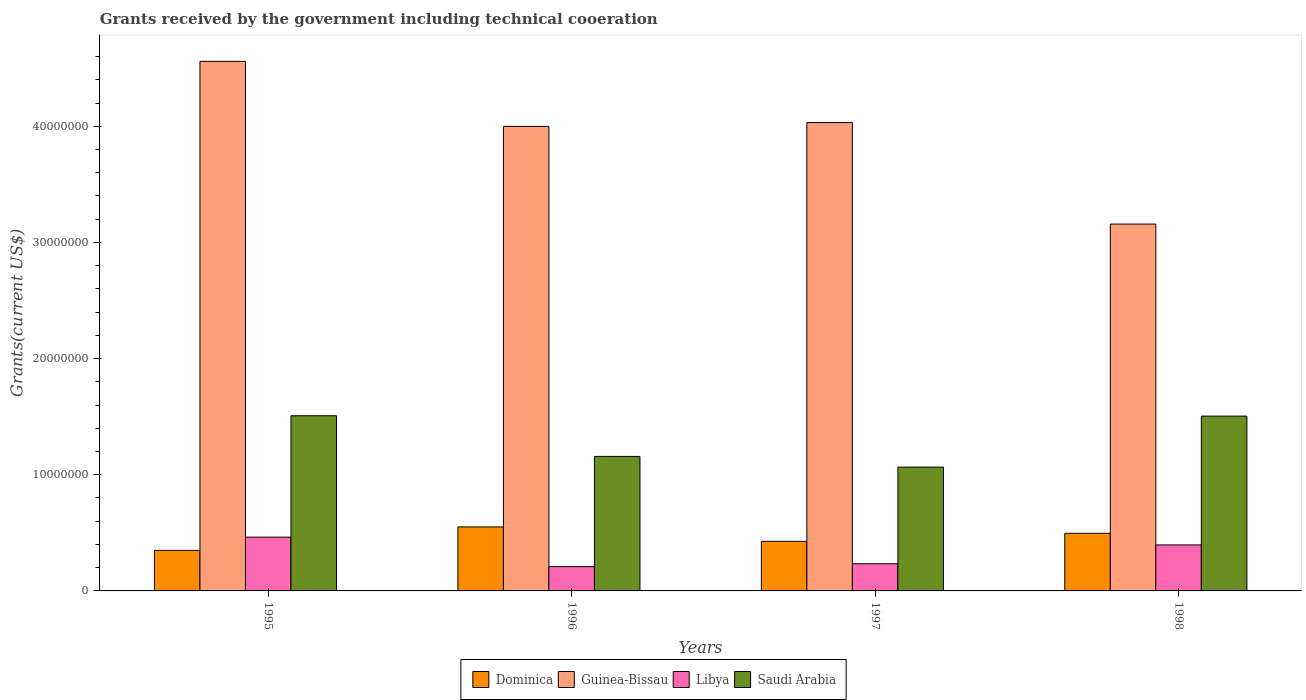How many different coloured bars are there?
Offer a very short reply. 4. How many groups of bars are there?
Your response must be concise. 4. Are the number of bars per tick equal to the number of legend labels?
Your answer should be very brief. Yes. In how many cases, is the number of bars for a given year not equal to the number of legend labels?
Your response must be concise. 0. What is the total grants received by the government in Saudi Arabia in 1995?
Provide a succinct answer. 1.51e+07. Across all years, what is the maximum total grants received by the government in Saudi Arabia?
Give a very brief answer. 1.51e+07. Across all years, what is the minimum total grants received by the government in Saudi Arabia?
Your answer should be very brief. 1.07e+07. In which year was the total grants received by the government in Saudi Arabia maximum?
Keep it short and to the point. 1995. What is the total total grants received by the government in Dominica in the graph?
Your answer should be very brief. 1.82e+07. What is the difference between the total grants received by the government in Guinea-Bissau in 1995 and that in 1998?
Provide a short and direct response. 1.40e+07. What is the difference between the total grants received by the government in Guinea-Bissau in 1998 and the total grants received by the government in Libya in 1995?
Offer a terse response. 2.70e+07. What is the average total grants received by the government in Dominica per year?
Your answer should be very brief. 4.56e+06. In the year 1998, what is the difference between the total grants received by the government in Libya and total grants received by the government in Saudi Arabia?
Ensure brevity in your answer.  -1.11e+07. In how many years, is the total grants received by the government in Dominica greater than 20000000 US$?
Ensure brevity in your answer.  0. What is the ratio of the total grants received by the government in Saudi Arabia in 1997 to that in 1998?
Offer a terse response. 0.71. Is the total grants received by the government in Libya in 1996 less than that in 1998?
Offer a terse response. Yes. Is the difference between the total grants received by the government in Libya in 1995 and 1998 greater than the difference between the total grants received by the government in Saudi Arabia in 1995 and 1998?
Provide a short and direct response. Yes. What is the difference between the highest and the second highest total grants received by the government in Saudi Arabia?
Give a very brief answer. 3.00e+04. What is the difference between the highest and the lowest total grants received by the government in Guinea-Bissau?
Make the answer very short. 1.40e+07. In how many years, is the total grants received by the government in Libya greater than the average total grants received by the government in Libya taken over all years?
Give a very brief answer. 2. Is it the case that in every year, the sum of the total grants received by the government in Guinea-Bissau and total grants received by the government in Dominica is greater than the sum of total grants received by the government in Saudi Arabia and total grants received by the government in Libya?
Your answer should be very brief. Yes. What does the 2nd bar from the left in 1998 represents?
Offer a very short reply. Guinea-Bissau. What does the 1st bar from the right in 1998 represents?
Make the answer very short. Saudi Arabia. Is it the case that in every year, the sum of the total grants received by the government in Libya and total grants received by the government in Saudi Arabia is greater than the total grants received by the government in Guinea-Bissau?
Your answer should be compact. No. How many bars are there?
Ensure brevity in your answer.  16. Are all the bars in the graph horizontal?
Give a very brief answer. No. What is the difference between two consecutive major ticks on the Y-axis?
Ensure brevity in your answer.  1.00e+07. Are the values on the major ticks of Y-axis written in scientific E-notation?
Offer a terse response. No. Does the graph contain any zero values?
Ensure brevity in your answer.  No. Does the graph contain grids?
Provide a short and direct response. No. Where does the legend appear in the graph?
Give a very brief answer. Bottom center. What is the title of the graph?
Make the answer very short. Grants received by the government including technical cooeration. Does "Congo (Democratic)" appear as one of the legend labels in the graph?
Provide a short and direct response. No. What is the label or title of the Y-axis?
Your answer should be compact. Grants(current US$). What is the Grants(current US$) in Dominica in 1995?
Give a very brief answer. 3.49e+06. What is the Grants(current US$) of Guinea-Bissau in 1995?
Your answer should be compact. 4.56e+07. What is the Grants(current US$) in Libya in 1995?
Make the answer very short. 4.63e+06. What is the Grants(current US$) of Saudi Arabia in 1995?
Offer a terse response. 1.51e+07. What is the Grants(current US$) in Dominica in 1996?
Keep it short and to the point. 5.51e+06. What is the Grants(current US$) of Guinea-Bissau in 1996?
Provide a succinct answer. 4.00e+07. What is the Grants(current US$) in Libya in 1996?
Offer a terse response. 2.09e+06. What is the Grants(current US$) of Saudi Arabia in 1996?
Make the answer very short. 1.16e+07. What is the Grants(current US$) in Dominica in 1997?
Provide a succinct answer. 4.27e+06. What is the Grants(current US$) in Guinea-Bissau in 1997?
Give a very brief answer. 4.03e+07. What is the Grants(current US$) of Libya in 1997?
Make the answer very short. 2.34e+06. What is the Grants(current US$) of Saudi Arabia in 1997?
Give a very brief answer. 1.07e+07. What is the Grants(current US$) in Dominica in 1998?
Your answer should be compact. 4.96e+06. What is the Grants(current US$) in Guinea-Bissau in 1998?
Give a very brief answer. 3.16e+07. What is the Grants(current US$) of Libya in 1998?
Offer a very short reply. 3.96e+06. What is the Grants(current US$) of Saudi Arabia in 1998?
Offer a very short reply. 1.50e+07. Across all years, what is the maximum Grants(current US$) of Dominica?
Give a very brief answer. 5.51e+06. Across all years, what is the maximum Grants(current US$) in Guinea-Bissau?
Your answer should be very brief. 4.56e+07. Across all years, what is the maximum Grants(current US$) of Libya?
Keep it short and to the point. 4.63e+06. Across all years, what is the maximum Grants(current US$) of Saudi Arabia?
Your answer should be very brief. 1.51e+07. Across all years, what is the minimum Grants(current US$) of Dominica?
Offer a very short reply. 3.49e+06. Across all years, what is the minimum Grants(current US$) in Guinea-Bissau?
Give a very brief answer. 3.16e+07. Across all years, what is the minimum Grants(current US$) of Libya?
Your answer should be compact. 2.09e+06. Across all years, what is the minimum Grants(current US$) in Saudi Arabia?
Keep it short and to the point. 1.07e+07. What is the total Grants(current US$) of Dominica in the graph?
Provide a succinct answer. 1.82e+07. What is the total Grants(current US$) in Guinea-Bissau in the graph?
Make the answer very short. 1.57e+08. What is the total Grants(current US$) in Libya in the graph?
Your answer should be compact. 1.30e+07. What is the total Grants(current US$) in Saudi Arabia in the graph?
Offer a very short reply. 5.24e+07. What is the difference between the Grants(current US$) of Dominica in 1995 and that in 1996?
Your answer should be compact. -2.02e+06. What is the difference between the Grants(current US$) in Guinea-Bissau in 1995 and that in 1996?
Offer a terse response. 5.60e+06. What is the difference between the Grants(current US$) of Libya in 1995 and that in 1996?
Ensure brevity in your answer.  2.54e+06. What is the difference between the Grants(current US$) of Saudi Arabia in 1995 and that in 1996?
Offer a very short reply. 3.50e+06. What is the difference between the Grants(current US$) in Dominica in 1995 and that in 1997?
Your response must be concise. -7.80e+05. What is the difference between the Grants(current US$) of Guinea-Bissau in 1995 and that in 1997?
Offer a terse response. 5.27e+06. What is the difference between the Grants(current US$) in Libya in 1995 and that in 1997?
Keep it short and to the point. 2.29e+06. What is the difference between the Grants(current US$) of Saudi Arabia in 1995 and that in 1997?
Offer a very short reply. 4.42e+06. What is the difference between the Grants(current US$) of Dominica in 1995 and that in 1998?
Your response must be concise. -1.47e+06. What is the difference between the Grants(current US$) in Guinea-Bissau in 1995 and that in 1998?
Provide a succinct answer. 1.40e+07. What is the difference between the Grants(current US$) in Libya in 1995 and that in 1998?
Provide a short and direct response. 6.70e+05. What is the difference between the Grants(current US$) of Dominica in 1996 and that in 1997?
Your answer should be compact. 1.24e+06. What is the difference between the Grants(current US$) in Guinea-Bissau in 1996 and that in 1997?
Keep it short and to the point. -3.30e+05. What is the difference between the Grants(current US$) in Saudi Arabia in 1996 and that in 1997?
Your answer should be compact. 9.20e+05. What is the difference between the Grants(current US$) in Guinea-Bissau in 1996 and that in 1998?
Provide a succinct answer. 8.41e+06. What is the difference between the Grants(current US$) in Libya in 1996 and that in 1998?
Provide a succinct answer. -1.87e+06. What is the difference between the Grants(current US$) of Saudi Arabia in 1996 and that in 1998?
Offer a very short reply. -3.47e+06. What is the difference between the Grants(current US$) in Dominica in 1997 and that in 1998?
Provide a succinct answer. -6.90e+05. What is the difference between the Grants(current US$) in Guinea-Bissau in 1997 and that in 1998?
Ensure brevity in your answer.  8.74e+06. What is the difference between the Grants(current US$) of Libya in 1997 and that in 1998?
Make the answer very short. -1.62e+06. What is the difference between the Grants(current US$) of Saudi Arabia in 1997 and that in 1998?
Offer a terse response. -4.39e+06. What is the difference between the Grants(current US$) of Dominica in 1995 and the Grants(current US$) of Guinea-Bissau in 1996?
Your answer should be very brief. -3.65e+07. What is the difference between the Grants(current US$) in Dominica in 1995 and the Grants(current US$) in Libya in 1996?
Your answer should be very brief. 1.40e+06. What is the difference between the Grants(current US$) of Dominica in 1995 and the Grants(current US$) of Saudi Arabia in 1996?
Give a very brief answer. -8.09e+06. What is the difference between the Grants(current US$) of Guinea-Bissau in 1995 and the Grants(current US$) of Libya in 1996?
Your answer should be very brief. 4.35e+07. What is the difference between the Grants(current US$) in Guinea-Bissau in 1995 and the Grants(current US$) in Saudi Arabia in 1996?
Ensure brevity in your answer.  3.40e+07. What is the difference between the Grants(current US$) of Libya in 1995 and the Grants(current US$) of Saudi Arabia in 1996?
Your answer should be very brief. -6.95e+06. What is the difference between the Grants(current US$) in Dominica in 1995 and the Grants(current US$) in Guinea-Bissau in 1997?
Your response must be concise. -3.68e+07. What is the difference between the Grants(current US$) of Dominica in 1995 and the Grants(current US$) of Libya in 1997?
Make the answer very short. 1.15e+06. What is the difference between the Grants(current US$) of Dominica in 1995 and the Grants(current US$) of Saudi Arabia in 1997?
Provide a short and direct response. -7.17e+06. What is the difference between the Grants(current US$) in Guinea-Bissau in 1995 and the Grants(current US$) in Libya in 1997?
Your response must be concise. 4.32e+07. What is the difference between the Grants(current US$) in Guinea-Bissau in 1995 and the Grants(current US$) in Saudi Arabia in 1997?
Offer a terse response. 3.49e+07. What is the difference between the Grants(current US$) in Libya in 1995 and the Grants(current US$) in Saudi Arabia in 1997?
Give a very brief answer. -6.03e+06. What is the difference between the Grants(current US$) of Dominica in 1995 and the Grants(current US$) of Guinea-Bissau in 1998?
Give a very brief answer. -2.81e+07. What is the difference between the Grants(current US$) of Dominica in 1995 and the Grants(current US$) of Libya in 1998?
Ensure brevity in your answer.  -4.70e+05. What is the difference between the Grants(current US$) of Dominica in 1995 and the Grants(current US$) of Saudi Arabia in 1998?
Offer a very short reply. -1.16e+07. What is the difference between the Grants(current US$) of Guinea-Bissau in 1995 and the Grants(current US$) of Libya in 1998?
Your response must be concise. 4.16e+07. What is the difference between the Grants(current US$) in Guinea-Bissau in 1995 and the Grants(current US$) in Saudi Arabia in 1998?
Provide a short and direct response. 3.05e+07. What is the difference between the Grants(current US$) in Libya in 1995 and the Grants(current US$) in Saudi Arabia in 1998?
Ensure brevity in your answer.  -1.04e+07. What is the difference between the Grants(current US$) in Dominica in 1996 and the Grants(current US$) in Guinea-Bissau in 1997?
Give a very brief answer. -3.48e+07. What is the difference between the Grants(current US$) in Dominica in 1996 and the Grants(current US$) in Libya in 1997?
Make the answer very short. 3.17e+06. What is the difference between the Grants(current US$) of Dominica in 1996 and the Grants(current US$) of Saudi Arabia in 1997?
Offer a very short reply. -5.15e+06. What is the difference between the Grants(current US$) in Guinea-Bissau in 1996 and the Grants(current US$) in Libya in 1997?
Your answer should be very brief. 3.76e+07. What is the difference between the Grants(current US$) in Guinea-Bissau in 1996 and the Grants(current US$) in Saudi Arabia in 1997?
Offer a very short reply. 2.93e+07. What is the difference between the Grants(current US$) in Libya in 1996 and the Grants(current US$) in Saudi Arabia in 1997?
Offer a terse response. -8.57e+06. What is the difference between the Grants(current US$) in Dominica in 1996 and the Grants(current US$) in Guinea-Bissau in 1998?
Offer a terse response. -2.61e+07. What is the difference between the Grants(current US$) of Dominica in 1996 and the Grants(current US$) of Libya in 1998?
Offer a terse response. 1.55e+06. What is the difference between the Grants(current US$) in Dominica in 1996 and the Grants(current US$) in Saudi Arabia in 1998?
Give a very brief answer. -9.54e+06. What is the difference between the Grants(current US$) of Guinea-Bissau in 1996 and the Grants(current US$) of Libya in 1998?
Your answer should be very brief. 3.60e+07. What is the difference between the Grants(current US$) in Guinea-Bissau in 1996 and the Grants(current US$) in Saudi Arabia in 1998?
Your response must be concise. 2.49e+07. What is the difference between the Grants(current US$) in Libya in 1996 and the Grants(current US$) in Saudi Arabia in 1998?
Provide a succinct answer. -1.30e+07. What is the difference between the Grants(current US$) in Dominica in 1997 and the Grants(current US$) in Guinea-Bissau in 1998?
Offer a terse response. -2.73e+07. What is the difference between the Grants(current US$) in Dominica in 1997 and the Grants(current US$) in Libya in 1998?
Give a very brief answer. 3.10e+05. What is the difference between the Grants(current US$) in Dominica in 1997 and the Grants(current US$) in Saudi Arabia in 1998?
Give a very brief answer. -1.08e+07. What is the difference between the Grants(current US$) in Guinea-Bissau in 1997 and the Grants(current US$) in Libya in 1998?
Your response must be concise. 3.64e+07. What is the difference between the Grants(current US$) in Guinea-Bissau in 1997 and the Grants(current US$) in Saudi Arabia in 1998?
Your response must be concise. 2.53e+07. What is the difference between the Grants(current US$) in Libya in 1997 and the Grants(current US$) in Saudi Arabia in 1998?
Make the answer very short. -1.27e+07. What is the average Grants(current US$) in Dominica per year?
Your answer should be very brief. 4.56e+06. What is the average Grants(current US$) of Guinea-Bissau per year?
Offer a terse response. 3.94e+07. What is the average Grants(current US$) of Libya per year?
Your response must be concise. 3.26e+06. What is the average Grants(current US$) in Saudi Arabia per year?
Your answer should be very brief. 1.31e+07. In the year 1995, what is the difference between the Grants(current US$) of Dominica and Grants(current US$) of Guinea-Bissau?
Provide a succinct answer. -4.21e+07. In the year 1995, what is the difference between the Grants(current US$) of Dominica and Grants(current US$) of Libya?
Provide a short and direct response. -1.14e+06. In the year 1995, what is the difference between the Grants(current US$) of Dominica and Grants(current US$) of Saudi Arabia?
Your response must be concise. -1.16e+07. In the year 1995, what is the difference between the Grants(current US$) in Guinea-Bissau and Grants(current US$) in Libya?
Keep it short and to the point. 4.10e+07. In the year 1995, what is the difference between the Grants(current US$) of Guinea-Bissau and Grants(current US$) of Saudi Arabia?
Give a very brief answer. 3.05e+07. In the year 1995, what is the difference between the Grants(current US$) of Libya and Grants(current US$) of Saudi Arabia?
Provide a succinct answer. -1.04e+07. In the year 1996, what is the difference between the Grants(current US$) in Dominica and Grants(current US$) in Guinea-Bissau?
Keep it short and to the point. -3.45e+07. In the year 1996, what is the difference between the Grants(current US$) of Dominica and Grants(current US$) of Libya?
Give a very brief answer. 3.42e+06. In the year 1996, what is the difference between the Grants(current US$) in Dominica and Grants(current US$) in Saudi Arabia?
Offer a terse response. -6.07e+06. In the year 1996, what is the difference between the Grants(current US$) of Guinea-Bissau and Grants(current US$) of Libya?
Make the answer very short. 3.79e+07. In the year 1996, what is the difference between the Grants(current US$) in Guinea-Bissau and Grants(current US$) in Saudi Arabia?
Provide a short and direct response. 2.84e+07. In the year 1996, what is the difference between the Grants(current US$) of Libya and Grants(current US$) of Saudi Arabia?
Ensure brevity in your answer.  -9.49e+06. In the year 1997, what is the difference between the Grants(current US$) in Dominica and Grants(current US$) in Guinea-Bissau?
Give a very brief answer. -3.60e+07. In the year 1997, what is the difference between the Grants(current US$) in Dominica and Grants(current US$) in Libya?
Your answer should be compact. 1.93e+06. In the year 1997, what is the difference between the Grants(current US$) of Dominica and Grants(current US$) of Saudi Arabia?
Make the answer very short. -6.39e+06. In the year 1997, what is the difference between the Grants(current US$) of Guinea-Bissau and Grants(current US$) of Libya?
Make the answer very short. 3.80e+07. In the year 1997, what is the difference between the Grants(current US$) of Guinea-Bissau and Grants(current US$) of Saudi Arabia?
Your answer should be very brief. 2.97e+07. In the year 1997, what is the difference between the Grants(current US$) in Libya and Grants(current US$) in Saudi Arabia?
Offer a terse response. -8.32e+06. In the year 1998, what is the difference between the Grants(current US$) in Dominica and Grants(current US$) in Guinea-Bissau?
Your response must be concise. -2.66e+07. In the year 1998, what is the difference between the Grants(current US$) of Dominica and Grants(current US$) of Saudi Arabia?
Ensure brevity in your answer.  -1.01e+07. In the year 1998, what is the difference between the Grants(current US$) of Guinea-Bissau and Grants(current US$) of Libya?
Your response must be concise. 2.76e+07. In the year 1998, what is the difference between the Grants(current US$) in Guinea-Bissau and Grants(current US$) in Saudi Arabia?
Provide a short and direct response. 1.65e+07. In the year 1998, what is the difference between the Grants(current US$) of Libya and Grants(current US$) of Saudi Arabia?
Provide a short and direct response. -1.11e+07. What is the ratio of the Grants(current US$) of Dominica in 1995 to that in 1996?
Your response must be concise. 0.63. What is the ratio of the Grants(current US$) in Guinea-Bissau in 1995 to that in 1996?
Your answer should be compact. 1.14. What is the ratio of the Grants(current US$) in Libya in 1995 to that in 1996?
Give a very brief answer. 2.22. What is the ratio of the Grants(current US$) of Saudi Arabia in 1995 to that in 1996?
Your answer should be compact. 1.3. What is the ratio of the Grants(current US$) in Dominica in 1995 to that in 1997?
Make the answer very short. 0.82. What is the ratio of the Grants(current US$) in Guinea-Bissau in 1995 to that in 1997?
Ensure brevity in your answer.  1.13. What is the ratio of the Grants(current US$) of Libya in 1995 to that in 1997?
Your answer should be compact. 1.98. What is the ratio of the Grants(current US$) of Saudi Arabia in 1995 to that in 1997?
Keep it short and to the point. 1.41. What is the ratio of the Grants(current US$) in Dominica in 1995 to that in 1998?
Your response must be concise. 0.7. What is the ratio of the Grants(current US$) in Guinea-Bissau in 1995 to that in 1998?
Your answer should be very brief. 1.44. What is the ratio of the Grants(current US$) of Libya in 1995 to that in 1998?
Your answer should be compact. 1.17. What is the ratio of the Grants(current US$) of Saudi Arabia in 1995 to that in 1998?
Your response must be concise. 1. What is the ratio of the Grants(current US$) of Dominica in 1996 to that in 1997?
Your answer should be compact. 1.29. What is the ratio of the Grants(current US$) of Guinea-Bissau in 1996 to that in 1997?
Offer a very short reply. 0.99. What is the ratio of the Grants(current US$) of Libya in 1996 to that in 1997?
Ensure brevity in your answer.  0.89. What is the ratio of the Grants(current US$) of Saudi Arabia in 1996 to that in 1997?
Provide a short and direct response. 1.09. What is the ratio of the Grants(current US$) in Dominica in 1996 to that in 1998?
Give a very brief answer. 1.11. What is the ratio of the Grants(current US$) in Guinea-Bissau in 1996 to that in 1998?
Make the answer very short. 1.27. What is the ratio of the Grants(current US$) in Libya in 1996 to that in 1998?
Make the answer very short. 0.53. What is the ratio of the Grants(current US$) in Saudi Arabia in 1996 to that in 1998?
Ensure brevity in your answer.  0.77. What is the ratio of the Grants(current US$) in Dominica in 1997 to that in 1998?
Your response must be concise. 0.86. What is the ratio of the Grants(current US$) in Guinea-Bissau in 1997 to that in 1998?
Provide a succinct answer. 1.28. What is the ratio of the Grants(current US$) of Libya in 1997 to that in 1998?
Give a very brief answer. 0.59. What is the ratio of the Grants(current US$) in Saudi Arabia in 1997 to that in 1998?
Keep it short and to the point. 0.71. What is the difference between the highest and the second highest Grants(current US$) of Guinea-Bissau?
Provide a short and direct response. 5.27e+06. What is the difference between the highest and the second highest Grants(current US$) in Libya?
Keep it short and to the point. 6.70e+05. What is the difference between the highest and the second highest Grants(current US$) of Saudi Arabia?
Keep it short and to the point. 3.00e+04. What is the difference between the highest and the lowest Grants(current US$) of Dominica?
Your answer should be very brief. 2.02e+06. What is the difference between the highest and the lowest Grants(current US$) of Guinea-Bissau?
Make the answer very short. 1.40e+07. What is the difference between the highest and the lowest Grants(current US$) of Libya?
Keep it short and to the point. 2.54e+06. What is the difference between the highest and the lowest Grants(current US$) of Saudi Arabia?
Ensure brevity in your answer.  4.42e+06. 